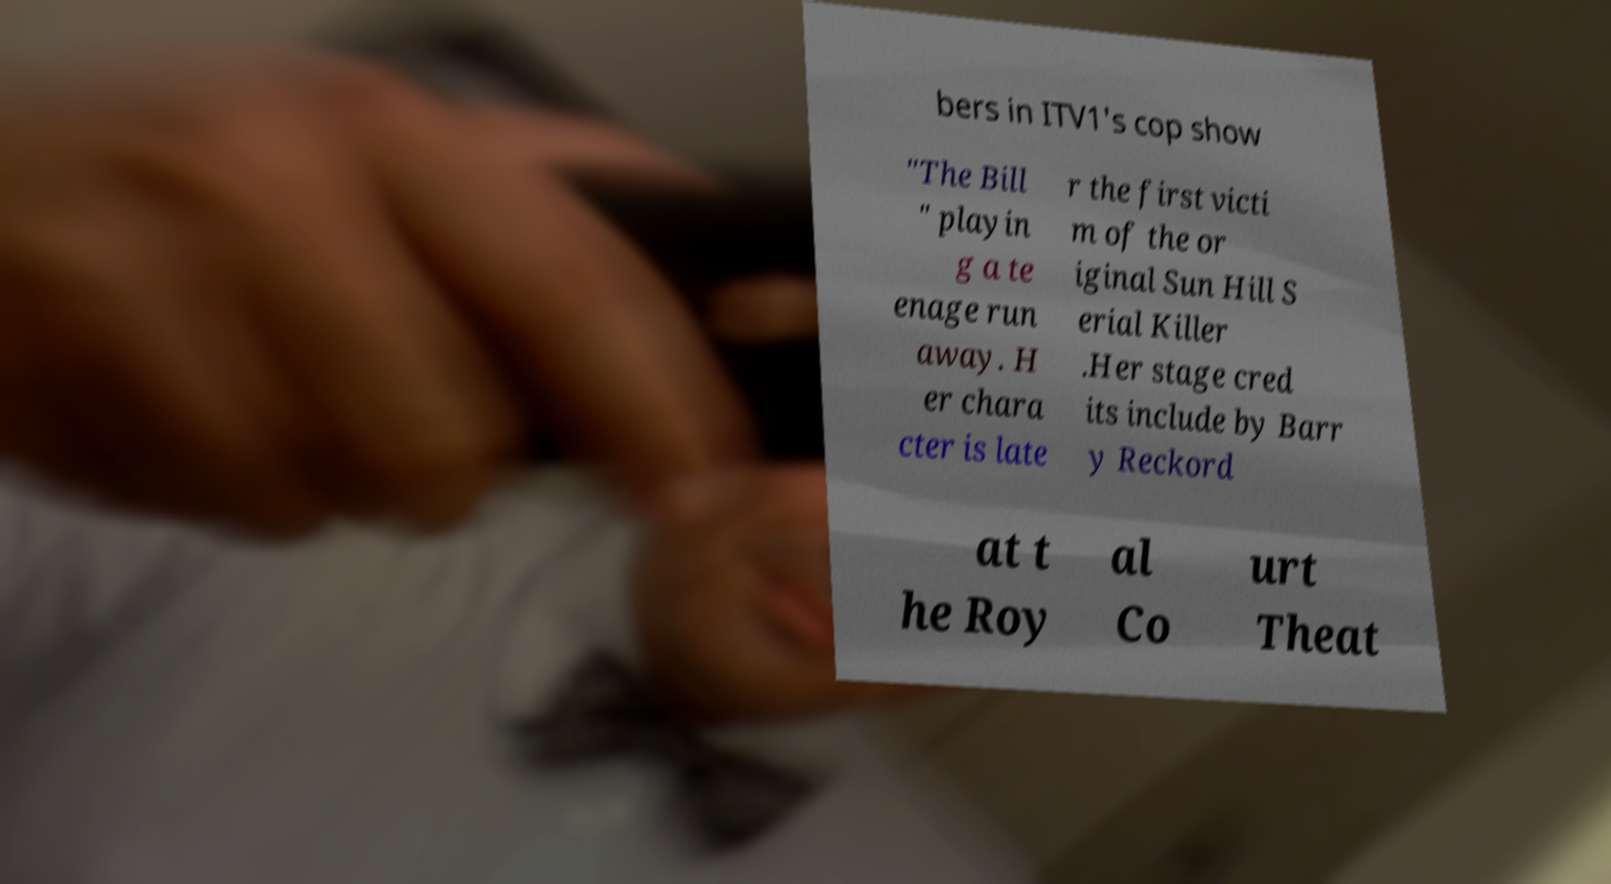Could you extract and type out the text from this image? bers in ITV1's cop show "The Bill " playin g a te enage run away. H er chara cter is late r the first victi m of the or iginal Sun Hill S erial Killer .Her stage cred its include by Barr y Reckord at t he Roy al Co urt Theat 